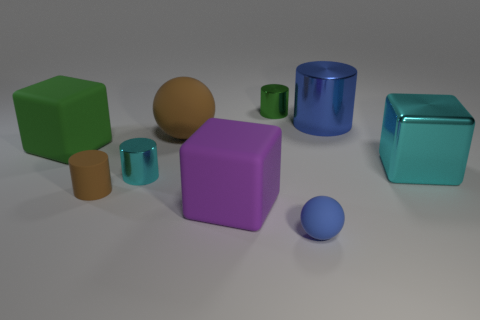Subtract all cylinders. How many objects are left? 5 Subtract 1 blue spheres. How many objects are left? 8 Subtract all large red metallic cubes. Subtract all tiny matte things. How many objects are left? 7 Add 3 brown rubber spheres. How many brown rubber spheres are left? 4 Add 9 brown cylinders. How many brown cylinders exist? 10 